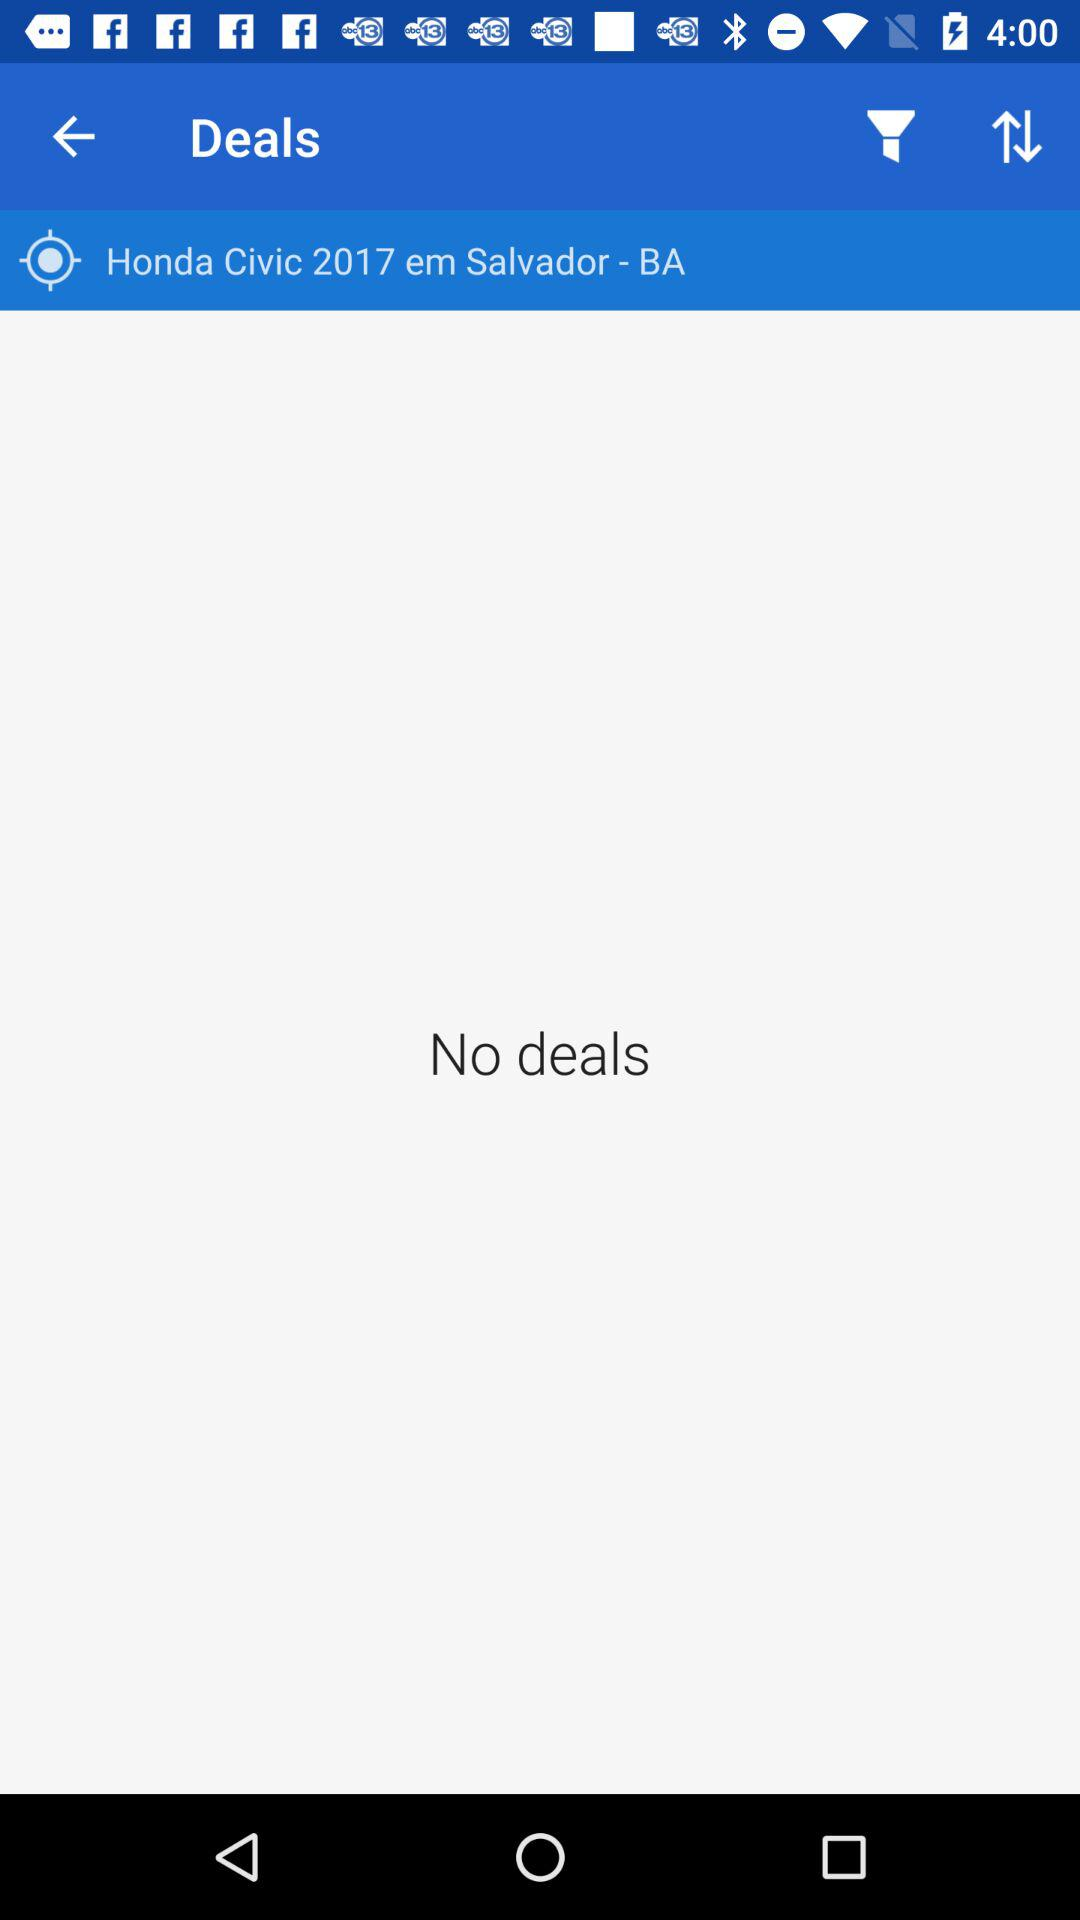What model of car is given? The given model of car is "Civic". 